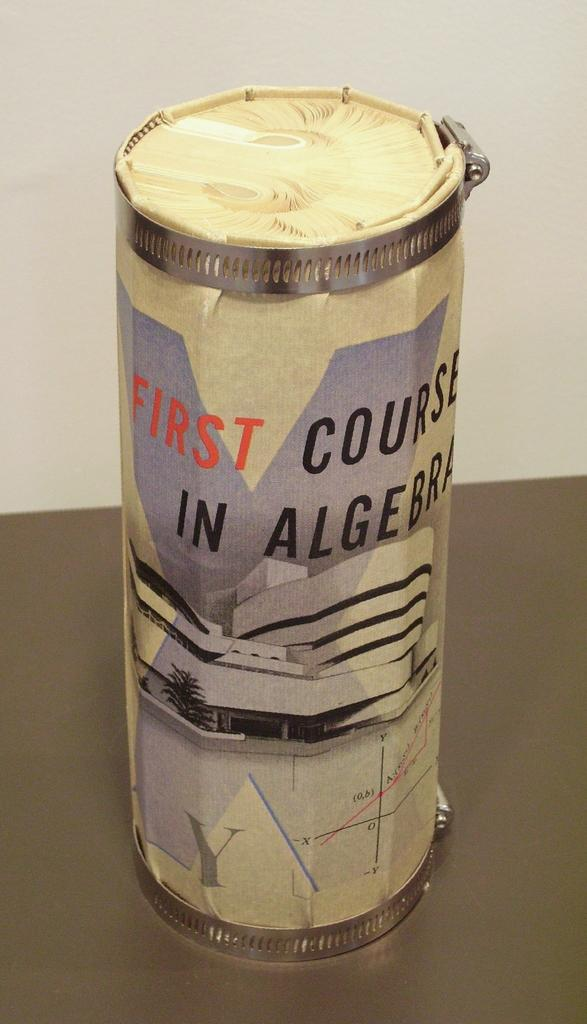Provide a one-sentence caption for the provided image. A paper tube is labeled "First Course in Algebra.". 